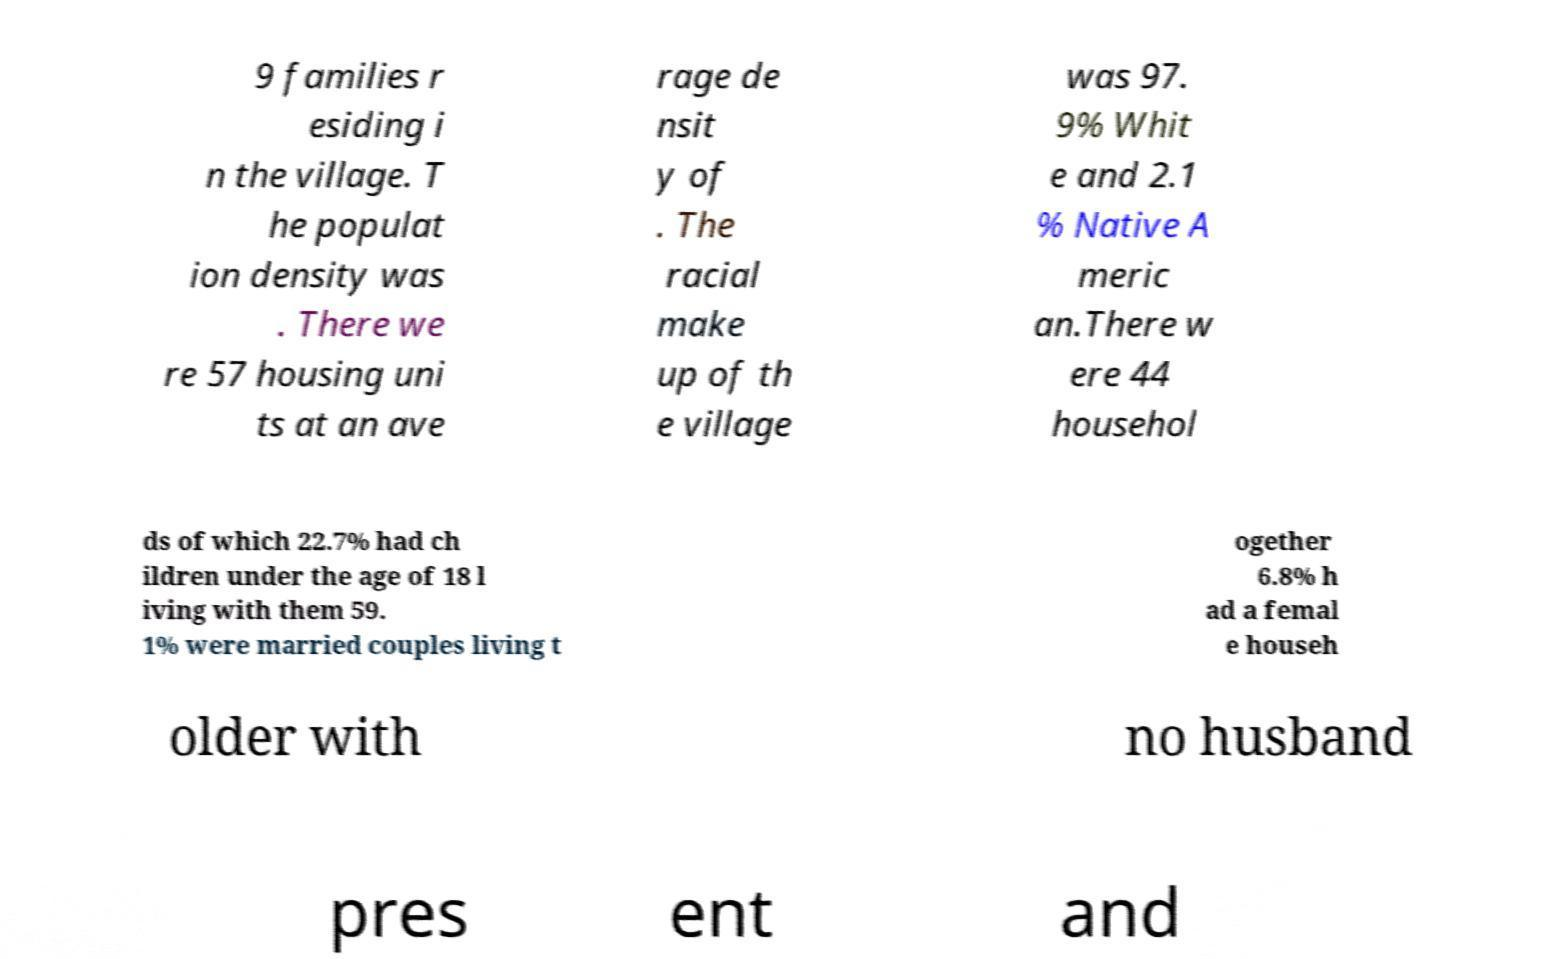Can you accurately transcribe the text from the provided image for me? 9 families r esiding i n the village. T he populat ion density was . There we re 57 housing uni ts at an ave rage de nsit y of . The racial make up of th e village was 97. 9% Whit e and 2.1 % Native A meric an.There w ere 44 househol ds of which 22.7% had ch ildren under the age of 18 l iving with them 59. 1% were married couples living t ogether 6.8% h ad a femal e househ older with no husband pres ent and 